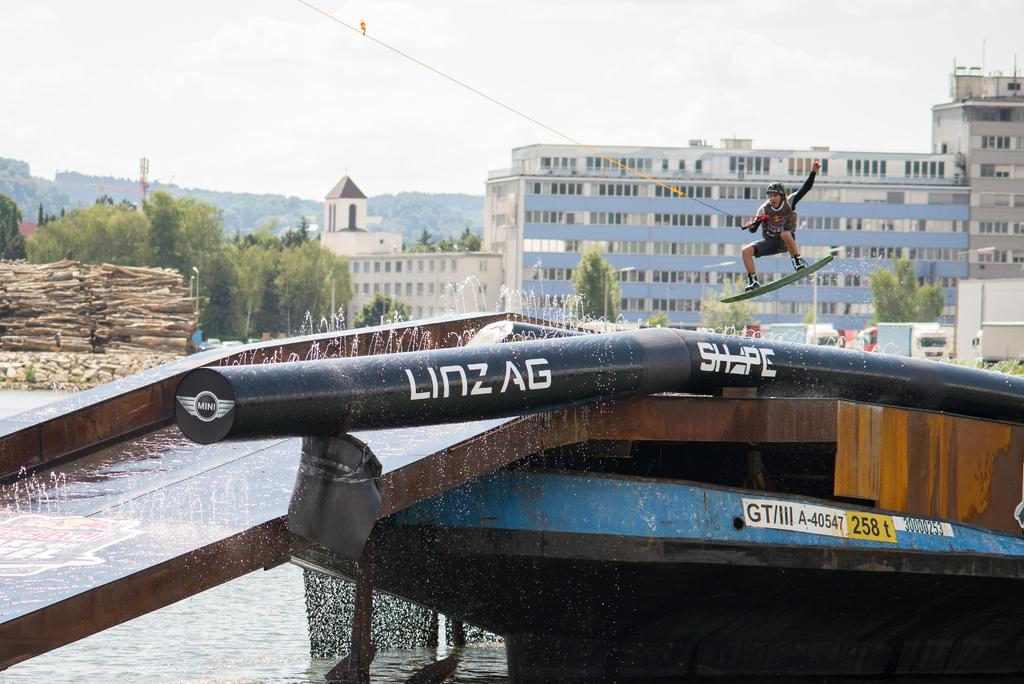<image>
Describe the image concisely. A man wearing a helmet on a board goes over a Linzag tube. 